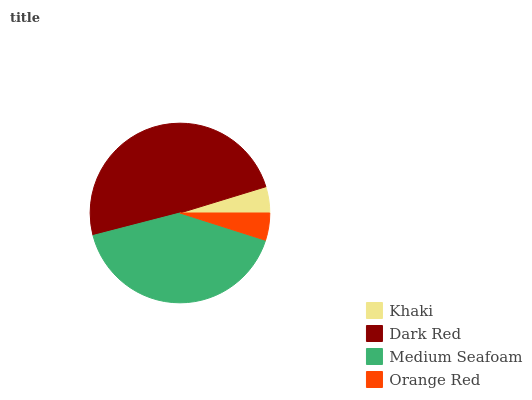Is Khaki the minimum?
Answer yes or no. Yes. Is Dark Red the maximum?
Answer yes or no. Yes. Is Medium Seafoam the minimum?
Answer yes or no. No. Is Medium Seafoam the maximum?
Answer yes or no. No. Is Dark Red greater than Medium Seafoam?
Answer yes or no. Yes. Is Medium Seafoam less than Dark Red?
Answer yes or no. Yes. Is Medium Seafoam greater than Dark Red?
Answer yes or no. No. Is Dark Red less than Medium Seafoam?
Answer yes or no. No. Is Medium Seafoam the high median?
Answer yes or no. Yes. Is Orange Red the low median?
Answer yes or no. Yes. Is Dark Red the high median?
Answer yes or no. No. Is Medium Seafoam the low median?
Answer yes or no. No. 